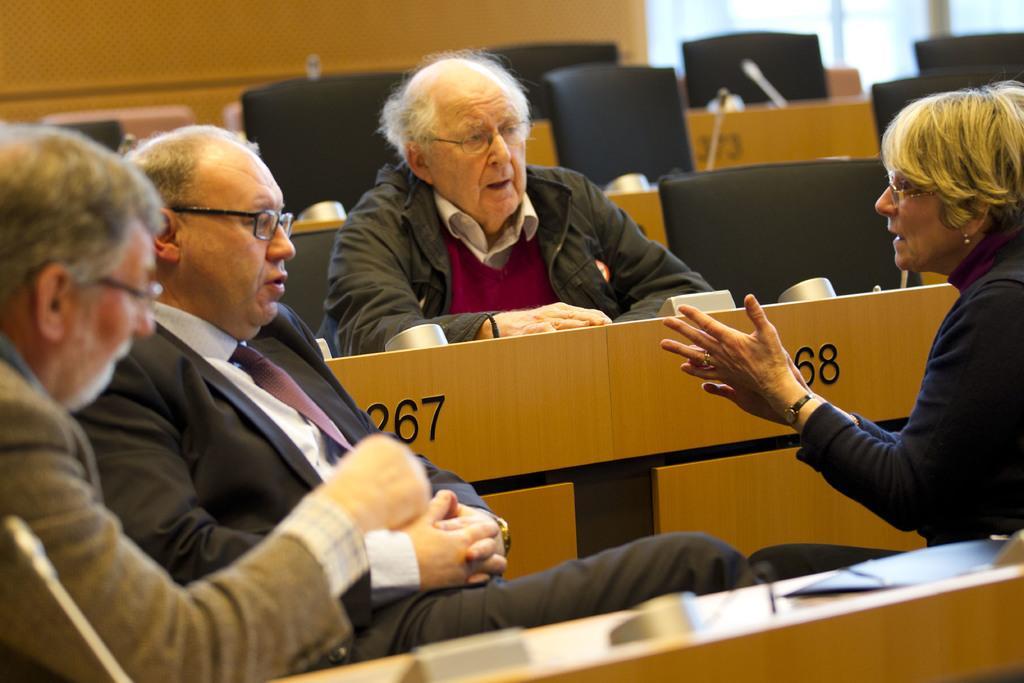Describe this image in one or two sentences. In the picture I can see people are sitting on chairs. Here I can see wooden objects on which I can see some numbers. In the background I can see black color chairs and other objects. 